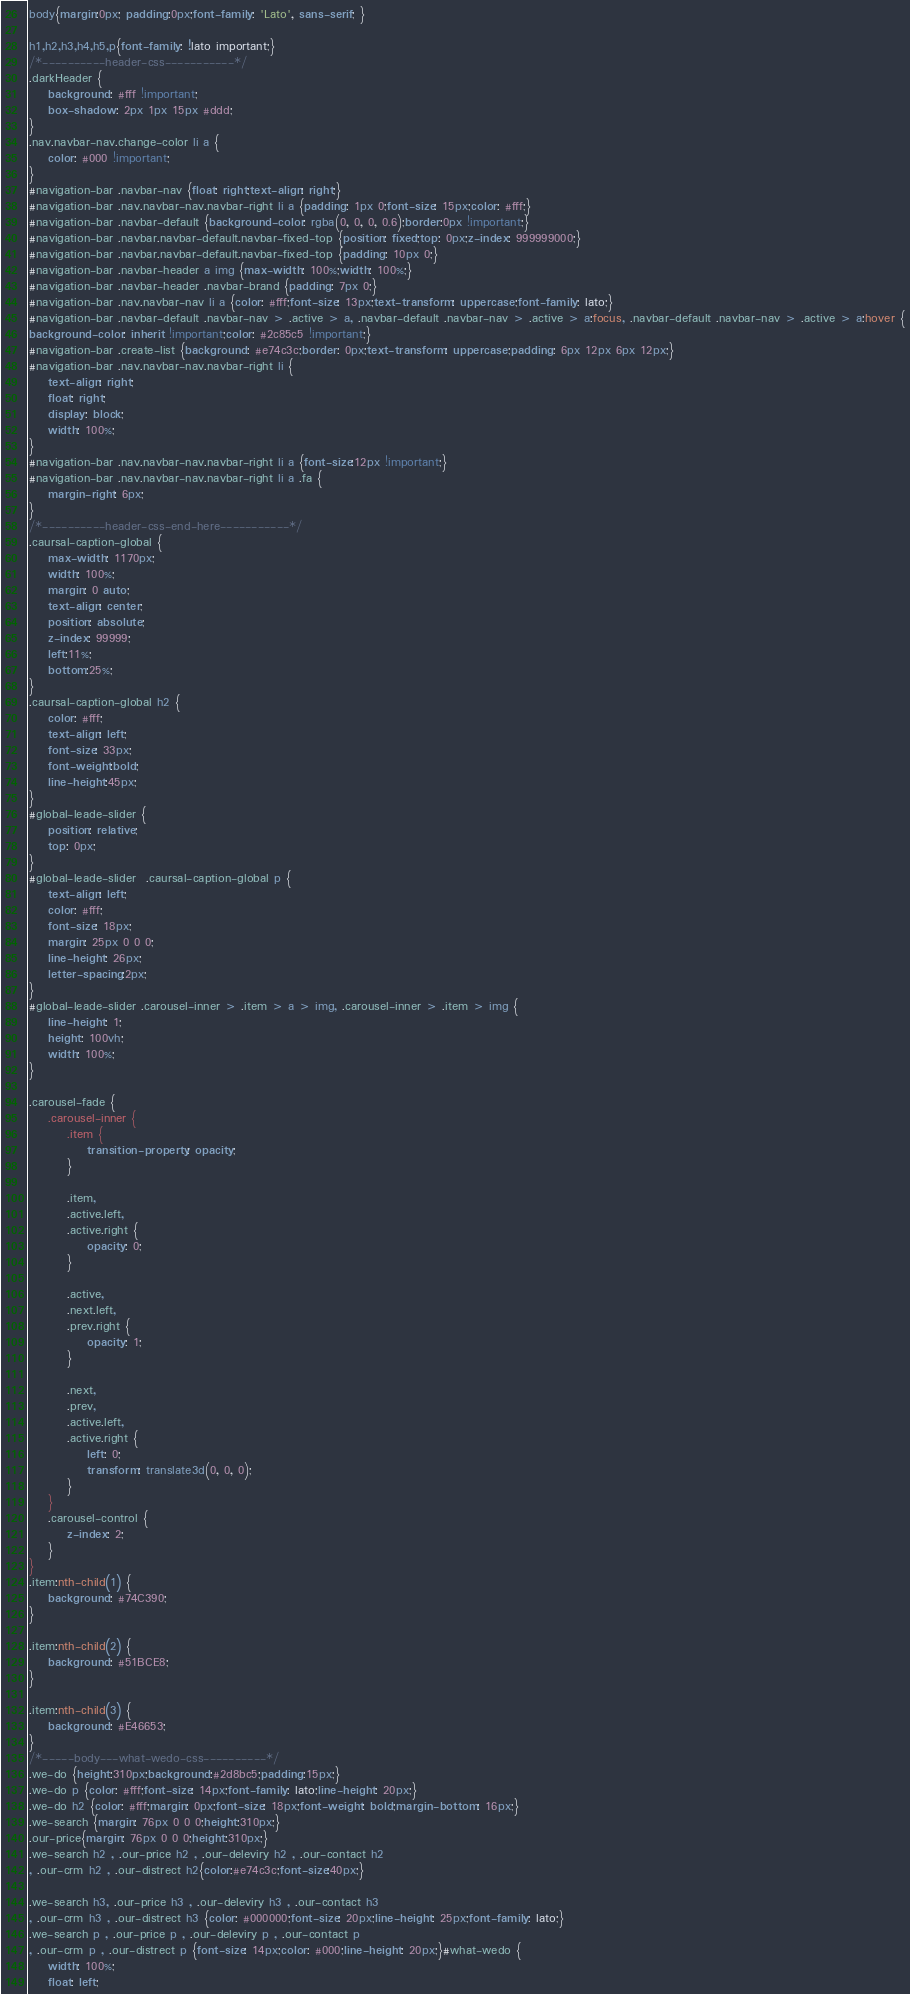Convert code to text. <code><loc_0><loc_0><loc_500><loc_500><_CSS_>body{margin:0px; padding:0px;font-family: 'Lato', sans-serif; }

h1,h2,h3,h4,h5,p{font-family: !lato important;}
/*----------header-css-----------*/
.darkHeader {
	background: #fff !important;
	box-shadow: 2px 1px 15px #ddd;
}
.nav.navbar-nav.change-color li a {
	color: #000 !important;
}
#navigation-bar .navbar-nav {float: right;text-align: right;}
#navigation-bar .nav.navbar-nav.navbar-right li a {padding: 1px 0;font-size: 15px;color: #fff;}
#navigation-bar .navbar-default {background-color: rgba(0, 0, 0, 0.6);border:0px !important;}
#navigation-bar .navbar.navbar-default.navbar-fixed-top {position: fixed;top: 0px;z-index: 999999000;}
#navigation-bar .navbar.navbar-default.navbar-fixed-top {padding: 10px 0;}
#navigation-bar .navbar-header a img {max-width: 100%;width: 100%;}
#navigation-bar .navbar-header .navbar-brand {padding: 7px 0;}
#navigation-bar .nav.navbar-nav li a {color: #fff;font-size: 13px;text-transform: uppercase;font-family: lato;}
#navigation-bar .navbar-default .navbar-nav > .active > a, .navbar-default .navbar-nav > .active > a:focus, .navbar-default .navbar-nav > .active > a:hover {
background-color: inherit !important;color: #2c85c5 !important;}
#navigation-bar .create-list {background: #e74c3c;border: 0px;text-transform: uppercase;padding: 6px 12px 6px 12px;}
#navigation-bar .nav.navbar-nav.navbar-right li {
	text-align: right;
	float: right;
	display: block;
	width: 100%;
}
#navigation-bar .nav.navbar-nav.navbar-right li a {font-size:12px !important;}
#navigation-bar .nav.navbar-nav.navbar-right li a .fa {
	margin-right: 6px;
}
/*----------header-css-end-here-----------*/
.caursal-caption-global {
	max-width: 1170px;
	width: 100%;
	margin: 0 auto;
	text-align: center;
	position: absolute;
	z-index: 99999;
	left:11%;
	bottom:25%;
}
.caursal-caption-global h2 {
	color: #fff;
	text-align: left;
	font-size: 33px;
	font-weight:bold;
	line-height:45px;
}
#global-leade-slider {
	position: relative;
	top: 0px;
}
#global-leade-slider  .caursal-caption-global p {
	text-align: left;
	color: #fff;
	font-size: 18px;
	margin: 25px 0 0 0;
	line-height: 26px;
	letter-spacing:2px;
}
#global-leade-slider .carousel-inner > .item > a > img, .carousel-inner > .item > img {
	line-height: 1;
	height: 100vh;
	width: 100%;
}

.carousel-fade {
    .carousel-inner {
        .item {
            transition-property: opacity;
        }
        
        .item,
        .active.left,
        .active.right {
            opacity: 0;
        }

        .active,
        .next.left,
        .prev.right {
            opacity: 1;
        }

        .next,
        .prev,
        .active.left,
        .active.right {
            left: 0;
            transform: translate3d(0, 0, 0);
        }
    }
    .carousel-control {
        z-index: 2;
    }
}
.item:nth-child(1) {
    background: #74C390;
}

.item:nth-child(2) {
    background: #51BCE8;
}

.item:nth-child(3) {
    background: #E46653;
}
/*-----body---what-wedo-css----------*/
.we-do {height:310px;background:#2d8bc5;padding:15px;}
.we-do p {color: #fff;font-size: 14px;font-family: lato;line-height: 20px;}
.we-do h2 {color: #fff;margin: 0px;font-size: 18px;font-weight: bold;margin-bottom: 16px;}
.we-search {margin: 76px 0 0 0;height:310px;}
.our-price{margin: 76px 0 0 0;height:310px;}
.we-search h2 , .our-price h2 , .our-deleviry h2 , .our-contact h2 
, .our-crm h2 , .our-distrect h2{color:#e74c3c;font-size:40px;}

.we-search h3, .our-price h3 , .our-deleviry h3 , .our-contact h3 
, .our-crm h3 , .our-distrect h3 {color: #000000;font-size: 20px;line-height: 25px;font-family: lato;}
.we-search p , .our-price p , .our-deleviry p , .our-contact p 
, .our-crm p , .our-distrect p {font-size: 14px;color: #000;line-height: 20px;}#what-wedo {
	width: 100%;
	float: left;</code> 